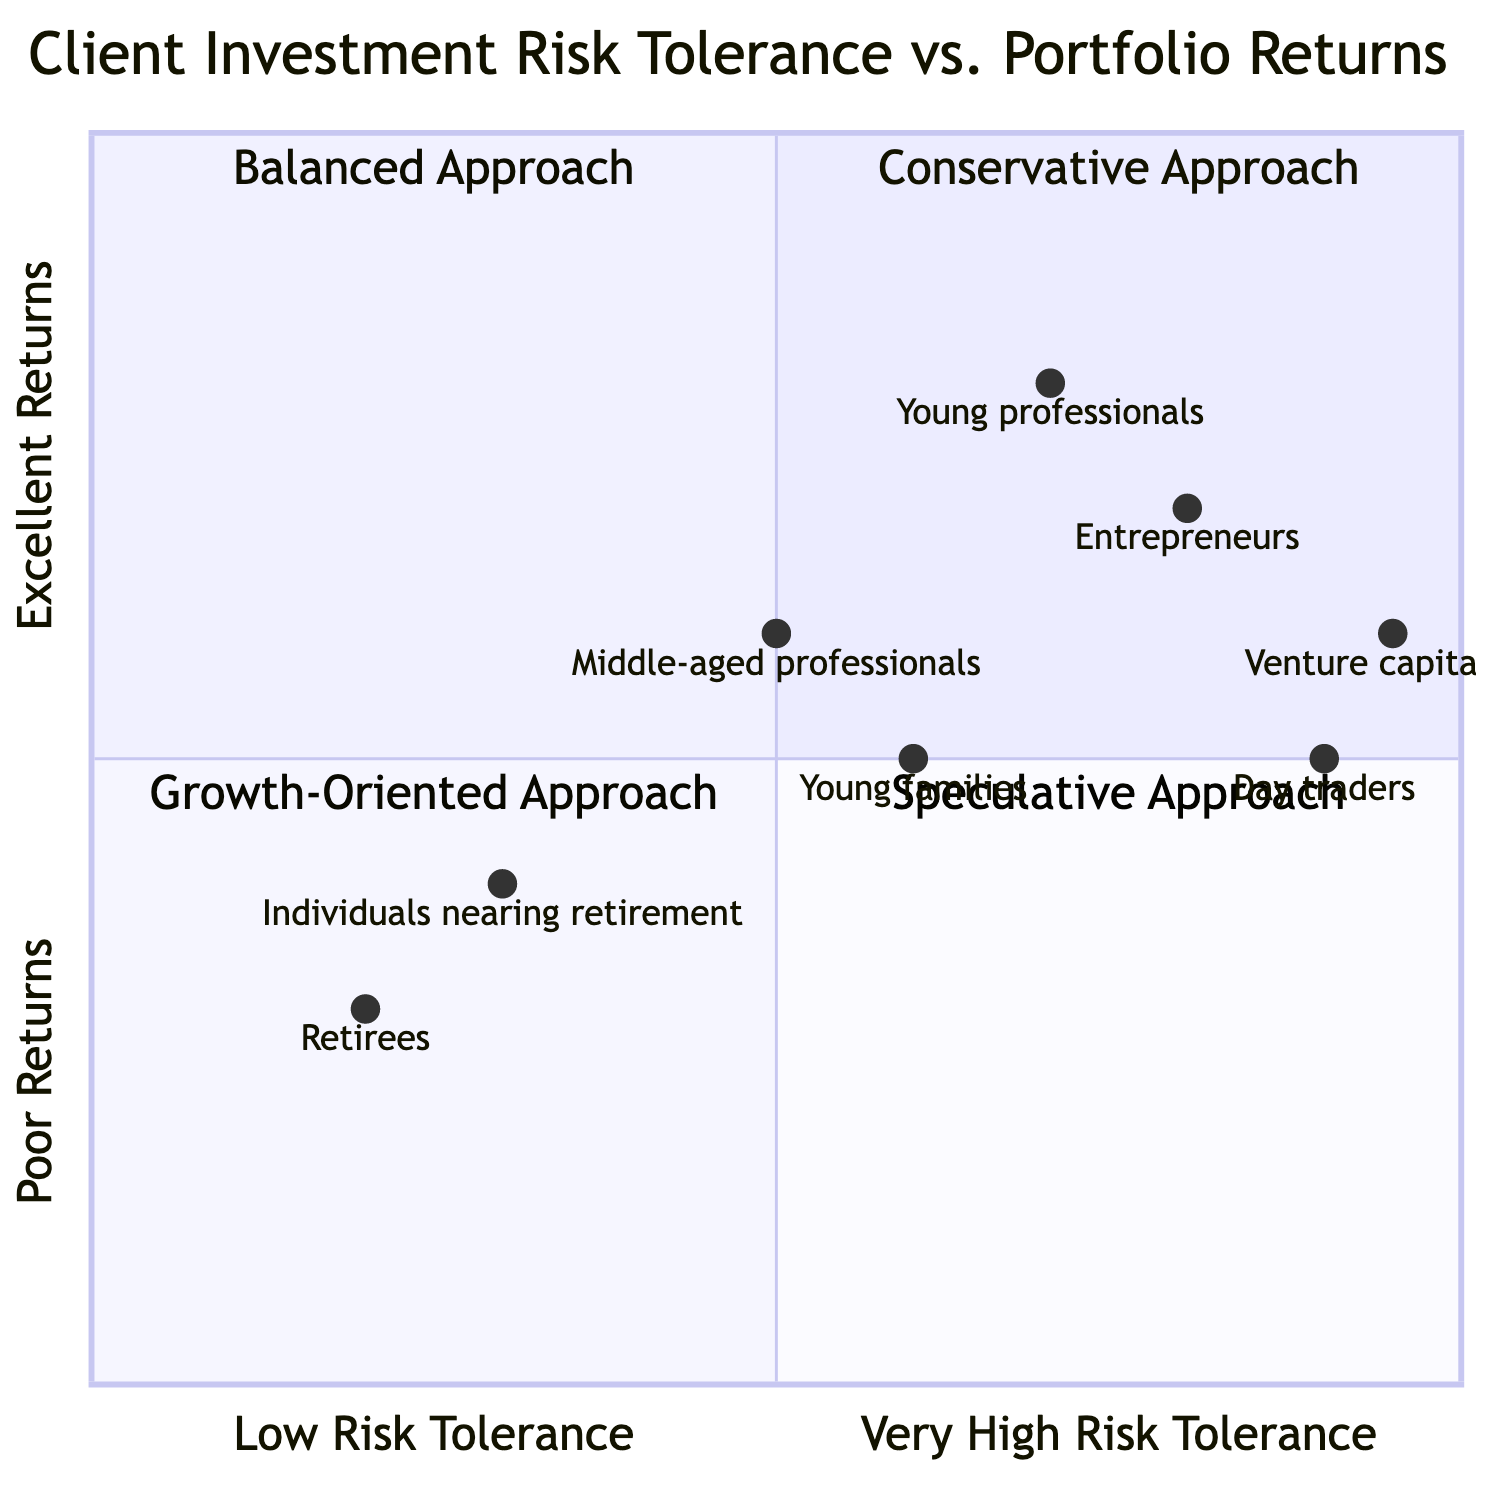What is the investment strategy for clients in the Conservative Approach? The Conservative Approach focuses on capital preservation and involves investing in bonds, treasury bills, and low-risk mutual funds. This information is directly given in the description of the quadrant for Conservative Approach.
Answer: Investment in bonds, treasury bills, and low-risk mutual funds Which client type is most likely to be in the Growth-Oriented Approach quadrant? The Growth-Oriented Approach quadrant describes clients like young professionals and entrepreneurs who typically seek high growth and can withstand market volatility. By identifying the example clients listed, young professionals fits this description.
Answer: Young professionals What is the risk tolerance for the Balanced Approach quadrant? The Balanced Approach quadrant lists clients as having medium risk tolerance, which is explicitly stated under risk tolerance for this quadrant.
Answer: Medium How many client types are represented in the Speculative Approach quadrant? In the Speculative Approach quadrant, two client types are mentioned: day traders and venture capitalists. Counting the example clients listed for this quadrant gives us the answer.
Answer: Two Which quadrant do clients with low risk tolerance and good returns typically fall into? Clients with low risk tolerance typically experience poor to average returns, which means they would not fall into a quadrant that represents good returns. They primarily belong in the Conservative Approach quadrant.
Answer: Conservative Approach What type of clients might be associated with a Balanced Approach? The Balanced Approach is associated with middle-aged professionals and young families who are moderately risk-tolerant and aim for average to good returns. This is mentioned in the description and client examples for this quadrant.
Answer: Middle-aged professionals, Young families What is the range of portfolio returns for clients with a very high risk tolerance? The Speculative Approach quadrant indicates that clients with very high risk tolerance can experience returns ranging from poor to excellent. This information is summarized in the description of the quadrant.
Answer: Poor to Excellent Which investment strategy is associated with clients in the Growth-Oriented Approach? The Growth-Oriented Approach involves aggressive investment strategies, including equities, growth mutual funds, REITs, and high-yield bonds. This information is explicitly stated in the quadrant's description.
Answer: Equities, growth mutual funds, REITs, and high-yield bonds 